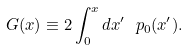<formula> <loc_0><loc_0><loc_500><loc_500>G ( x ) \equiv 2 \int _ { 0 } ^ { x } d x ^ { \prime } \ p _ { 0 } ( x ^ { \prime } ) .</formula> 